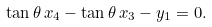<formula> <loc_0><loc_0><loc_500><loc_500>\tan \theta \, x _ { 4 } - \tan \theta \, x _ { 3 } - y _ { 1 } = 0 .</formula> 